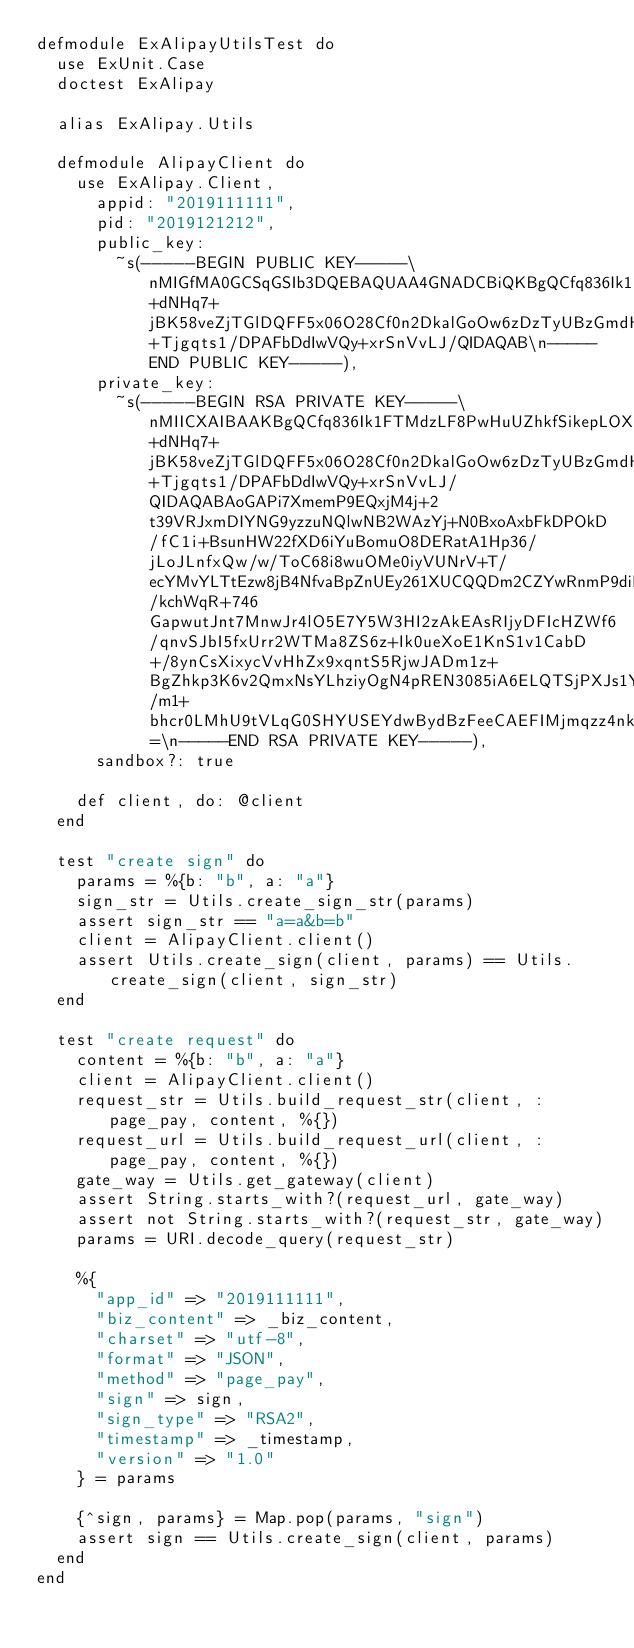Convert code to text. <code><loc_0><loc_0><loc_500><loc_500><_Elixir_>defmodule ExAlipayUtilsTest do
  use ExUnit.Case
  doctest ExAlipay

  alias ExAlipay.Utils

  defmodule AlipayClient do
    use ExAlipay.Client,
      appid: "2019111111",
      pid: "2019121212",
      public_key:
        ~s(-----BEGIN PUBLIC KEY-----\nMIGfMA0GCSqGSIb3DQEBAQUAA4GNADCBiQKBgQCfq836Ik1FTMdzLF8PwHuUZhkfSikepLOXCBGXs+dNHq7+jBK58veZjTGlDQFF5x06O28Cf0n2DkalGoOw6zDzTyUBzGmdH3n89uh7imFDATxZjDSMVLkdEVivpFePuyBnl78udqrLHG+Tjgqts1/DPAFbDdIwVQy+xrSnVvLJ/QIDAQAB\n-----END PUBLIC KEY-----),
      private_key:
        ~s(-----BEGIN RSA PRIVATE KEY-----\nMIICXAIBAAKBgQCfq836Ik1FTMdzLF8PwHuUZhkfSikepLOXCBGXs+dNHq7+jBK58veZjTGlDQFF5x06O28Cf0n2DkalGoOw6zDzTyUBzGmdH3n89uh7imFDATxZjDSMVLkdEVivpFePuyBnl78udqrLHG+Tjgqts1/DPAFbDdIwVQy+xrSnVvLJ/QIDAQABAoGAPi7XmemP9EQxjM4j+2t39VRJxmDIYNG9yzzuNQlwNB2WAzYj+N0BxoAxbFkDPOkD/fC1i+BsunHW22fXD6iYuBomuO8DERatA1Hp36/jLoJLnfxQw/w/ToC68i8wuOMe0iyVUNrV+T/ecYMvYLTtEzw8jB4NfvaBpZnUEy261XUCQQDm2CZYwRnmP9diMh7mKQHdCTUQ5crWyqImy8F0Y10gMO4j/kchWqR+746GapwutJnt7MnwJr4lO5E7Y5W3HI2zAkEAsRIjyDFIcHZWf6/qnvSJbI5fxUrr2WTMa8ZS6z+Ik0ueXoE1KnS1v1CabD+/8ynCsXixycVvHhZx9xqntS5RjwJADm1z+BgZhkp3K6v2QmxNsYLhziyOgN4pREN3085iA6ELQTSjPXJs1YIjZkNDf6fJ9xTViizhtXIDobKXqNogAQJAKOwSTO/m1+bhcr0LMhU9tVLqG0SHYUSEYdwBydBzFeeCAEFIMjmqzz4nkiDhkabzEeTc4c65MXDqgbstSxgbTQJBALkt3Xjun50XUDFY4YIVIj8c3Zi74HpXl667lzstf2sk8hwB7SLg3zT53o2RUjam4jk1GjFp8B68xT5B5WY2jOM=\n-----END RSA PRIVATE KEY-----),
      sandbox?: true

    def client, do: @client
  end

  test "create sign" do
    params = %{b: "b", a: "a"}
    sign_str = Utils.create_sign_str(params)
    assert sign_str == "a=a&b=b"
    client = AlipayClient.client()
    assert Utils.create_sign(client, params) == Utils.create_sign(client, sign_str)
  end

  test "create request" do
    content = %{b: "b", a: "a"}
    client = AlipayClient.client()
    request_str = Utils.build_request_str(client, :page_pay, content, %{})
    request_url = Utils.build_request_url(client, :page_pay, content, %{})
    gate_way = Utils.get_gateway(client)
    assert String.starts_with?(request_url, gate_way)
    assert not String.starts_with?(request_str, gate_way)
    params = URI.decode_query(request_str)

    %{
      "app_id" => "2019111111",
      "biz_content" => _biz_content,
      "charset" => "utf-8",
      "format" => "JSON",
      "method" => "page_pay",
      "sign" => sign,
      "sign_type" => "RSA2",
      "timestamp" => _timestamp,
      "version" => "1.0"
    } = params

    {^sign, params} = Map.pop(params, "sign")
    assert sign == Utils.create_sign(client, params)
  end
end
</code> 